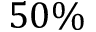<formula> <loc_0><loc_0><loc_500><loc_500>5 0 \%</formula> 